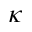<formula> <loc_0><loc_0><loc_500><loc_500>\kappa</formula> 